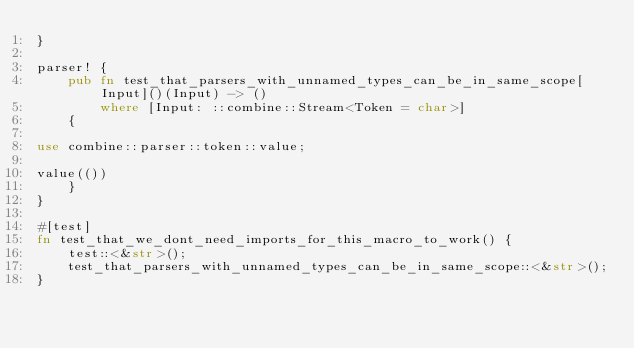Convert code to text. <code><loc_0><loc_0><loc_500><loc_500><_Rust_>}

parser! {
    pub fn test_that_parsers_with_unnamed_types_can_be_in_same_scope[Input]()(Input) -> ()
        where [Input: ::combine::Stream<Token = char>]
    {

use combine::parser::token::value;

value(())
    }
}

#[test]
fn test_that_we_dont_need_imports_for_this_macro_to_work() {
    test::<&str>();
    test_that_parsers_with_unnamed_types_can_be_in_same_scope::<&str>();
}
</code> 